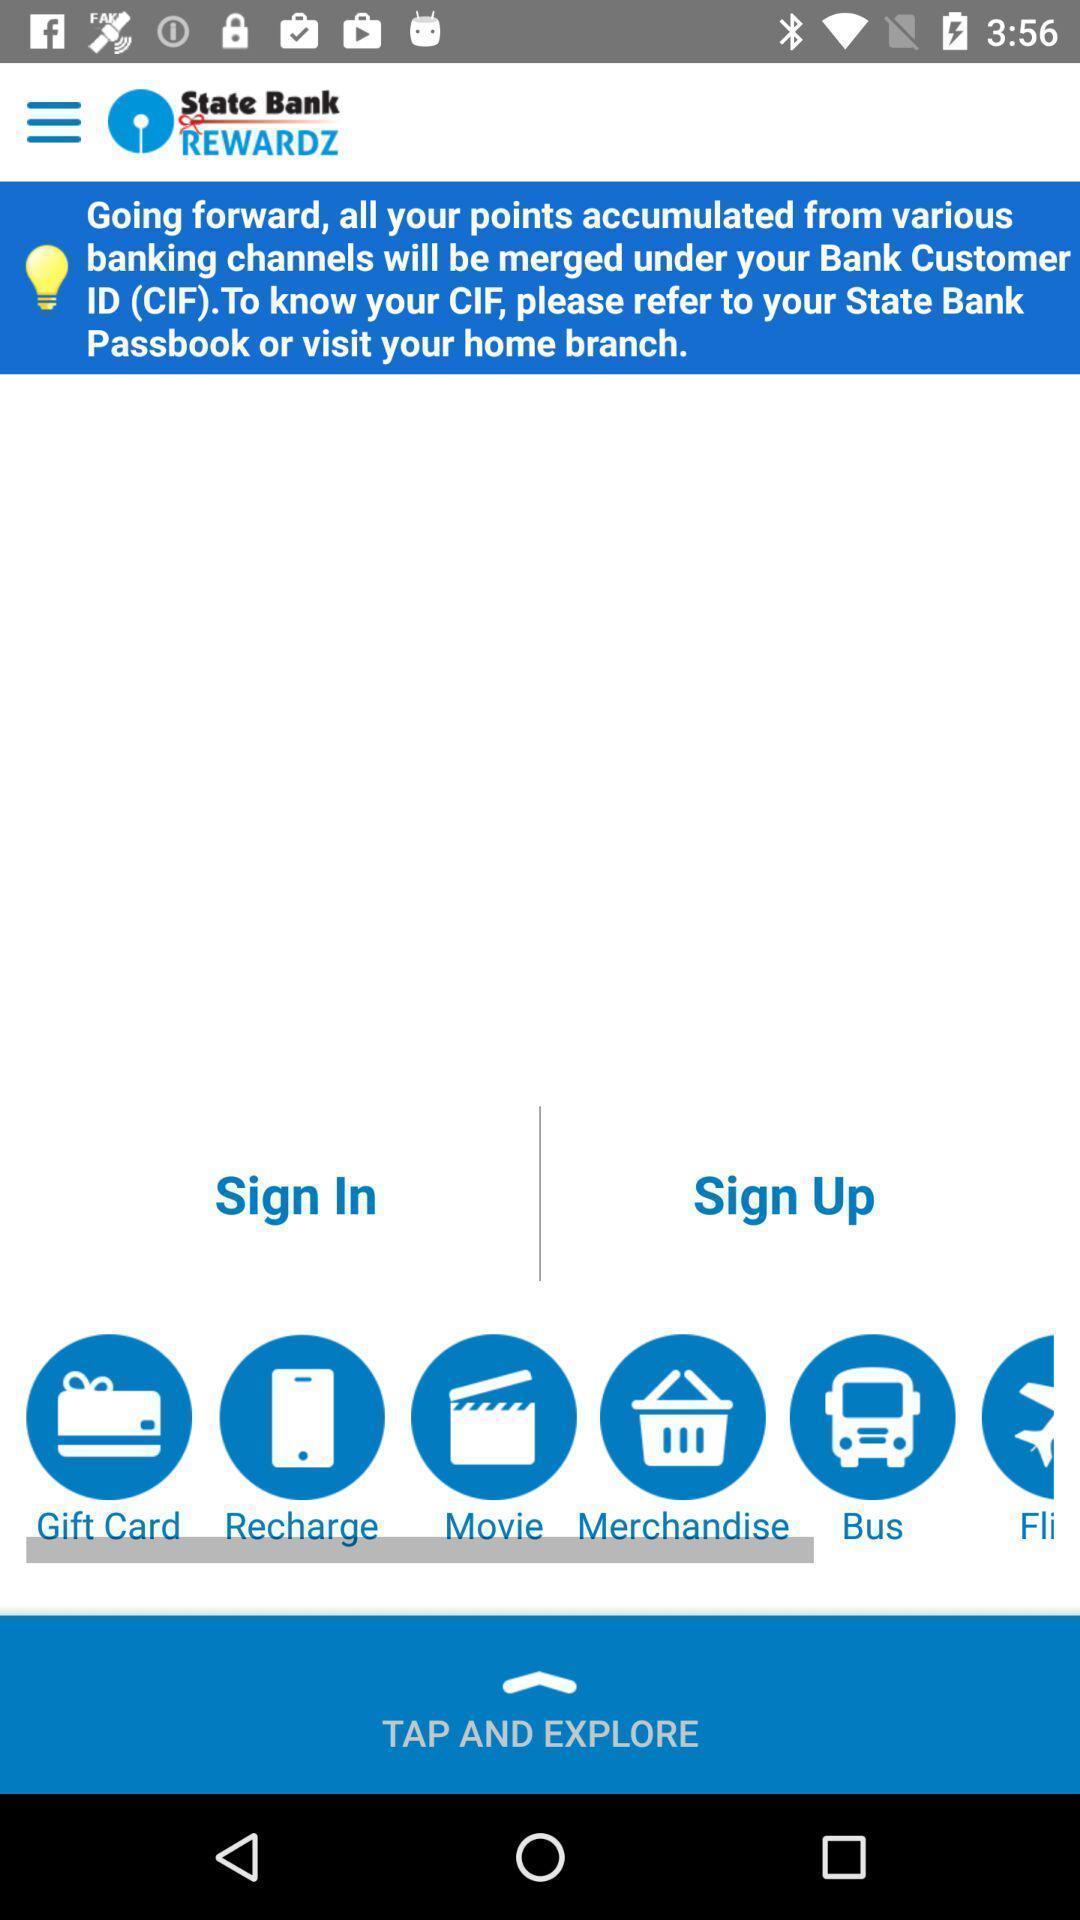What details can you identify in this image? Welcome page of a bank app. 